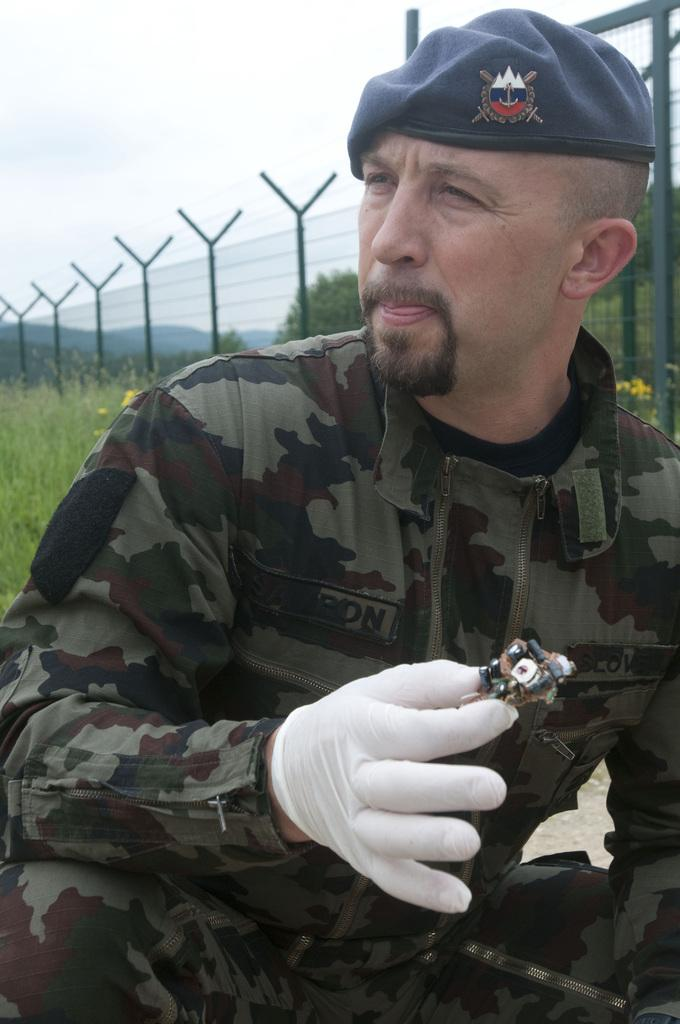What is the person in the image wearing? The person is wearing a military uniform and a cap. What is the person holding in their hand? The person is holding a circuit board in their hand. What can be seen in the background of the image? There is a fence and the sky visible in the background of the image. How many cars are parked near the person in the image? There are no cars visible in the image. What type of knot is the person tying in the image? There is no knot-tying activity depicted in the image. 